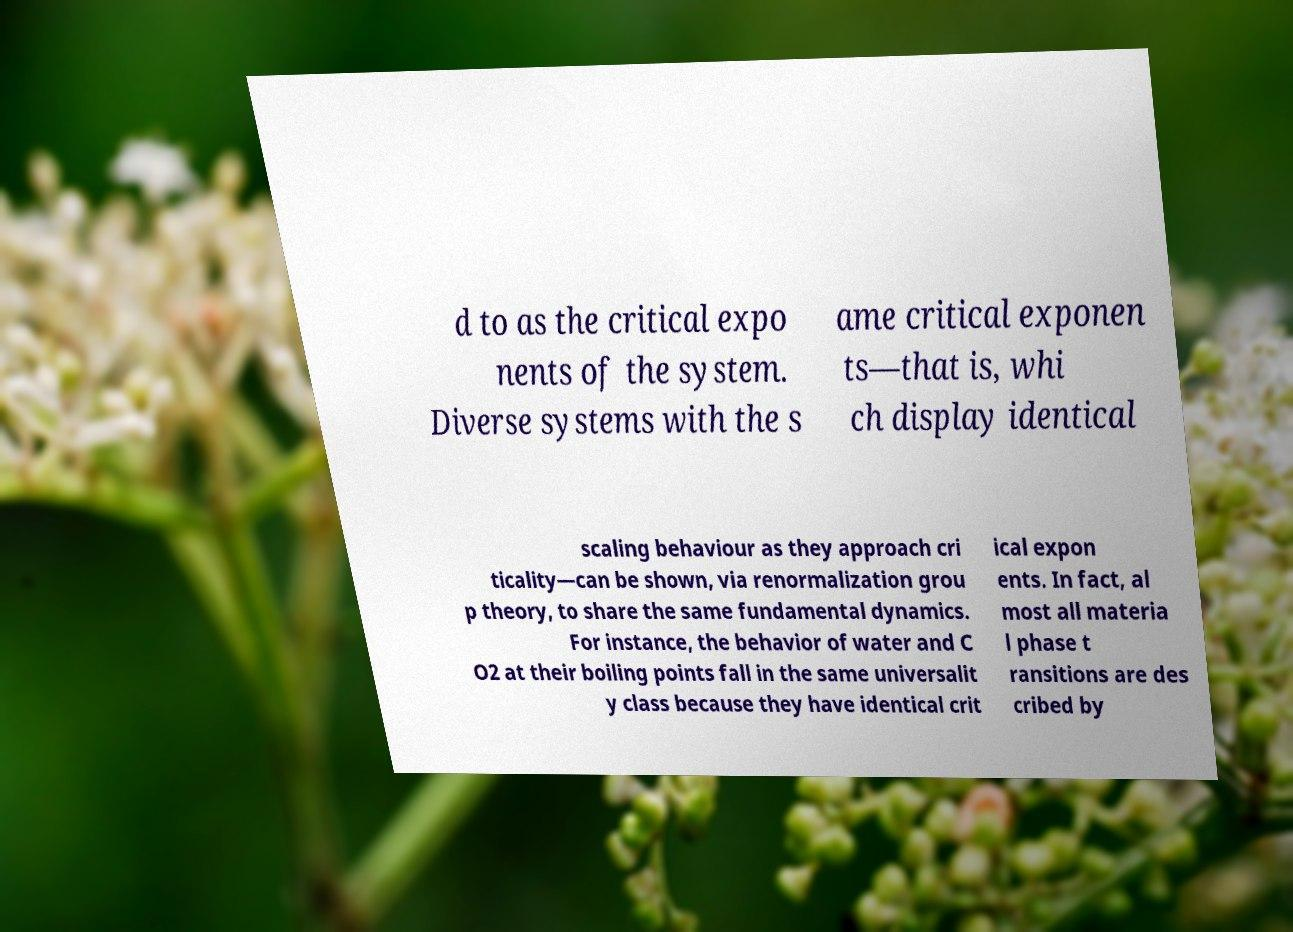Please identify and transcribe the text found in this image. d to as the critical expo nents of the system. Diverse systems with the s ame critical exponen ts—that is, whi ch display identical scaling behaviour as they approach cri ticality—can be shown, via renormalization grou p theory, to share the same fundamental dynamics. For instance, the behavior of water and C O2 at their boiling points fall in the same universalit y class because they have identical crit ical expon ents. In fact, al most all materia l phase t ransitions are des cribed by 